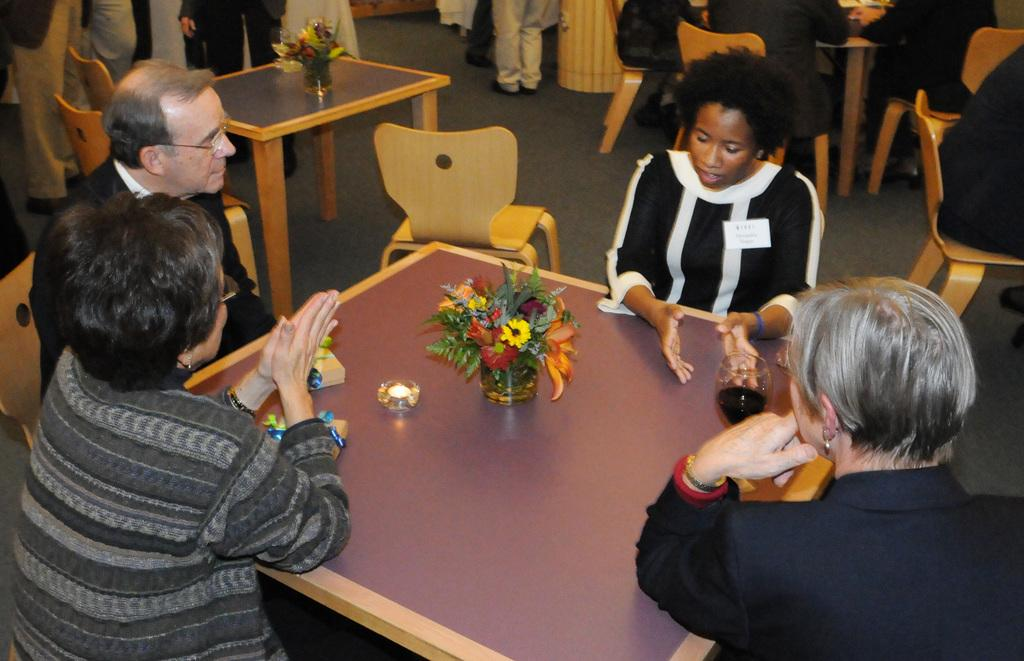How many people are present in the image? There are three women and a man in the image, making a total of four people. What are the people in the image doing? They are sitting around a table. What can be seen on the table? There is a flower vase on the table. What is happening in the background of the image? In the background, there are people standing and sitting. What type of toy can be seen in the elbow of the man in the image? There is no toy present in the image, and the man's elbow is not mentioned in the provided facts. 